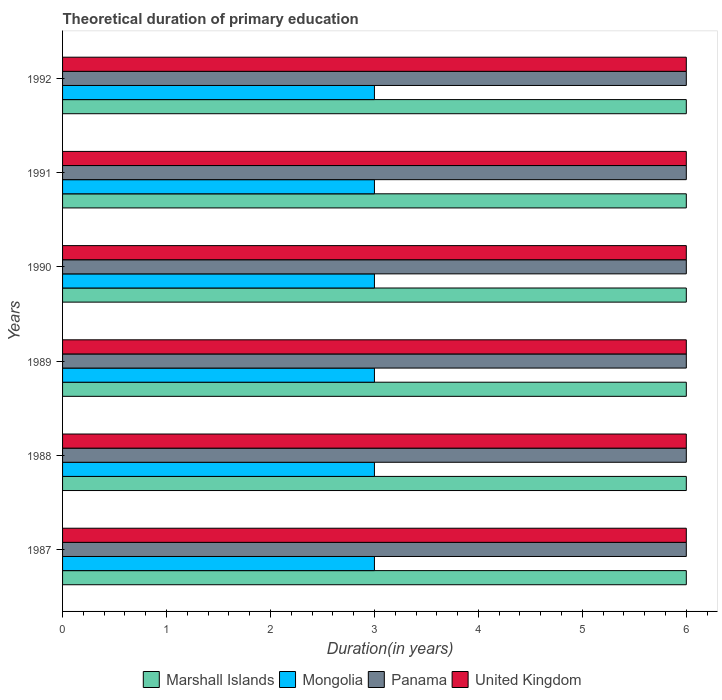Are the number of bars on each tick of the Y-axis equal?
Offer a terse response. Yes. How many bars are there on the 5th tick from the top?
Offer a very short reply. 4. Across all years, what is the maximum total theoretical duration of primary education in Mongolia?
Offer a very short reply. 3. In which year was the total theoretical duration of primary education in United Kingdom maximum?
Ensure brevity in your answer.  1987. What is the total total theoretical duration of primary education in Mongolia in the graph?
Make the answer very short. 18. What is the difference between the total theoretical duration of primary education in United Kingdom in 1987 and the total theoretical duration of primary education in Marshall Islands in 1988?
Give a very brief answer. 0. In the year 1991, what is the difference between the total theoretical duration of primary education in Marshall Islands and total theoretical duration of primary education in United Kingdom?
Keep it short and to the point. 0. In how many years, is the total theoretical duration of primary education in United Kingdom greater than 2.2 years?
Your answer should be compact. 6. What is the ratio of the total theoretical duration of primary education in Mongolia in 1988 to that in 1992?
Give a very brief answer. 1. Is the total theoretical duration of primary education in Mongolia in 1988 less than that in 1992?
Keep it short and to the point. No. Is the difference between the total theoretical duration of primary education in Marshall Islands in 1990 and 1992 greater than the difference between the total theoretical duration of primary education in United Kingdom in 1990 and 1992?
Make the answer very short. No. What is the difference between the highest and the lowest total theoretical duration of primary education in Panama?
Provide a succinct answer. 0. Is it the case that in every year, the sum of the total theoretical duration of primary education in Marshall Islands and total theoretical duration of primary education in Mongolia is greater than the sum of total theoretical duration of primary education in United Kingdom and total theoretical duration of primary education in Panama?
Ensure brevity in your answer.  No. What does the 3rd bar from the top in 1989 represents?
Provide a succinct answer. Mongolia. What does the 4th bar from the bottom in 1991 represents?
Offer a very short reply. United Kingdom. Is it the case that in every year, the sum of the total theoretical duration of primary education in Mongolia and total theoretical duration of primary education in Marshall Islands is greater than the total theoretical duration of primary education in Panama?
Ensure brevity in your answer.  Yes. Are all the bars in the graph horizontal?
Give a very brief answer. Yes. How many years are there in the graph?
Offer a very short reply. 6. Are the values on the major ticks of X-axis written in scientific E-notation?
Your answer should be compact. No. Where does the legend appear in the graph?
Offer a terse response. Bottom center. How many legend labels are there?
Your response must be concise. 4. What is the title of the graph?
Provide a succinct answer. Theoretical duration of primary education. What is the label or title of the X-axis?
Your answer should be compact. Duration(in years). What is the Duration(in years) in Marshall Islands in 1987?
Make the answer very short. 6. What is the Duration(in years) of Marshall Islands in 1988?
Provide a succinct answer. 6. What is the Duration(in years) in Panama in 1988?
Make the answer very short. 6. What is the Duration(in years) in Marshall Islands in 1989?
Keep it short and to the point. 6. What is the Duration(in years) in Marshall Islands in 1990?
Offer a very short reply. 6. What is the Duration(in years) in Panama in 1990?
Provide a short and direct response. 6. What is the Duration(in years) of Marshall Islands in 1991?
Offer a very short reply. 6. What is the Duration(in years) in Mongolia in 1991?
Your answer should be compact. 3. What is the Duration(in years) in Panama in 1991?
Ensure brevity in your answer.  6. What is the Duration(in years) in United Kingdom in 1991?
Make the answer very short. 6. What is the Duration(in years) in Marshall Islands in 1992?
Provide a succinct answer. 6. What is the Duration(in years) in Mongolia in 1992?
Your answer should be very brief. 3. What is the Duration(in years) in United Kingdom in 1992?
Give a very brief answer. 6. Across all years, what is the maximum Duration(in years) in Mongolia?
Your answer should be very brief. 3. Across all years, what is the maximum Duration(in years) of United Kingdom?
Your answer should be very brief. 6. Across all years, what is the minimum Duration(in years) of Marshall Islands?
Offer a terse response. 6. What is the total Duration(in years) of United Kingdom in the graph?
Your answer should be compact. 36. What is the difference between the Duration(in years) in Marshall Islands in 1987 and that in 1988?
Offer a terse response. 0. What is the difference between the Duration(in years) of Mongolia in 1987 and that in 1988?
Give a very brief answer. 0. What is the difference between the Duration(in years) of Mongolia in 1987 and that in 1990?
Make the answer very short. 0. What is the difference between the Duration(in years) of Marshall Islands in 1987 and that in 1991?
Your response must be concise. 0. What is the difference between the Duration(in years) in Panama in 1987 and that in 1991?
Your response must be concise. 0. What is the difference between the Duration(in years) of Panama in 1987 and that in 1992?
Give a very brief answer. 0. What is the difference between the Duration(in years) in Marshall Islands in 1988 and that in 1989?
Your answer should be compact. 0. What is the difference between the Duration(in years) in Panama in 1988 and that in 1989?
Make the answer very short. 0. What is the difference between the Duration(in years) in Mongolia in 1988 and that in 1990?
Make the answer very short. 0. What is the difference between the Duration(in years) in Panama in 1988 and that in 1991?
Your answer should be very brief. 0. What is the difference between the Duration(in years) in United Kingdom in 1988 and that in 1991?
Keep it short and to the point. 0. What is the difference between the Duration(in years) in Mongolia in 1988 and that in 1992?
Offer a terse response. 0. What is the difference between the Duration(in years) of Panama in 1988 and that in 1992?
Provide a short and direct response. 0. What is the difference between the Duration(in years) in Marshall Islands in 1989 and that in 1990?
Make the answer very short. 0. What is the difference between the Duration(in years) in United Kingdom in 1989 and that in 1990?
Offer a very short reply. 0. What is the difference between the Duration(in years) in Marshall Islands in 1989 and that in 1991?
Offer a very short reply. 0. What is the difference between the Duration(in years) of Panama in 1989 and that in 1991?
Give a very brief answer. 0. What is the difference between the Duration(in years) in United Kingdom in 1989 and that in 1991?
Offer a terse response. 0. What is the difference between the Duration(in years) of Marshall Islands in 1989 and that in 1992?
Offer a very short reply. 0. What is the difference between the Duration(in years) in Mongolia in 1989 and that in 1992?
Offer a terse response. 0. What is the difference between the Duration(in years) of United Kingdom in 1989 and that in 1992?
Provide a short and direct response. 0. What is the difference between the Duration(in years) in Mongolia in 1990 and that in 1991?
Offer a terse response. 0. What is the difference between the Duration(in years) of United Kingdom in 1990 and that in 1991?
Your answer should be compact. 0. What is the difference between the Duration(in years) in Marshall Islands in 1990 and that in 1992?
Your response must be concise. 0. What is the difference between the Duration(in years) of Mongolia in 1990 and that in 1992?
Offer a terse response. 0. What is the difference between the Duration(in years) in Marshall Islands in 1991 and that in 1992?
Your answer should be compact. 0. What is the difference between the Duration(in years) in Marshall Islands in 1987 and the Duration(in years) in Mongolia in 1988?
Provide a short and direct response. 3. What is the difference between the Duration(in years) in Marshall Islands in 1987 and the Duration(in years) in Panama in 1988?
Make the answer very short. 0. What is the difference between the Duration(in years) in Marshall Islands in 1987 and the Duration(in years) in United Kingdom in 1988?
Your response must be concise. 0. What is the difference between the Duration(in years) of Mongolia in 1987 and the Duration(in years) of Panama in 1988?
Provide a short and direct response. -3. What is the difference between the Duration(in years) in Marshall Islands in 1987 and the Duration(in years) in Mongolia in 1989?
Ensure brevity in your answer.  3. What is the difference between the Duration(in years) in Marshall Islands in 1987 and the Duration(in years) in United Kingdom in 1989?
Make the answer very short. 0. What is the difference between the Duration(in years) of Mongolia in 1987 and the Duration(in years) of Panama in 1989?
Your answer should be very brief. -3. What is the difference between the Duration(in years) in Mongolia in 1987 and the Duration(in years) in United Kingdom in 1989?
Keep it short and to the point. -3. What is the difference between the Duration(in years) in Marshall Islands in 1987 and the Duration(in years) in United Kingdom in 1990?
Offer a terse response. 0. What is the difference between the Duration(in years) in Mongolia in 1987 and the Duration(in years) in Panama in 1990?
Make the answer very short. -3. What is the difference between the Duration(in years) of Marshall Islands in 1987 and the Duration(in years) of Mongolia in 1991?
Offer a terse response. 3. What is the difference between the Duration(in years) in Mongolia in 1987 and the Duration(in years) in United Kingdom in 1991?
Your response must be concise. -3. What is the difference between the Duration(in years) in Mongolia in 1987 and the Duration(in years) in United Kingdom in 1992?
Your answer should be very brief. -3. What is the difference between the Duration(in years) of Marshall Islands in 1988 and the Duration(in years) of Mongolia in 1989?
Give a very brief answer. 3. What is the difference between the Duration(in years) in Marshall Islands in 1988 and the Duration(in years) in Panama in 1989?
Keep it short and to the point. 0. What is the difference between the Duration(in years) of Marshall Islands in 1988 and the Duration(in years) of United Kingdom in 1989?
Provide a short and direct response. 0. What is the difference between the Duration(in years) of Mongolia in 1988 and the Duration(in years) of United Kingdom in 1989?
Provide a succinct answer. -3. What is the difference between the Duration(in years) of Marshall Islands in 1988 and the Duration(in years) of Mongolia in 1990?
Keep it short and to the point. 3. What is the difference between the Duration(in years) of Marshall Islands in 1988 and the Duration(in years) of United Kingdom in 1990?
Keep it short and to the point. 0. What is the difference between the Duration(in years) of Mongolia in 1988 and the Duration(in years) of United Kingdom in 1990?
Offer a very short reply. -3. What is the difference between the Duration(in years) of Panama in 1988 and the Duration(in years) of United Kingdom in 1990?
Your answer should be very brief. 0. What is the difference between the Duration(in years) of Marshall Islands in 1988 and the Duration(in years) of United Kingdom in 1991?
Your answer should be compact. 0. What is the difference between the Duration(in years) of Mongolia in 1988 and the Duration(in years) of Panama in 1991?
Your response must be concise. -3. What is the difference between the Duration(in years) of Mongolia in 1988 and the Duration(in years) of United Kingdom in 1991?
Provide a succinct answer. -3. What is the difference between the Duration(in years) in Marshall Islands in 1988 and the Duration(in years) in Mongolia in 1992?
Your response must be concise. 3. What is the difference between the Duration(in years) of Mongolia in 1988 and the Duration(in years) of Panama in 1992?
Give a very brief answer. -3. What is the difference between the Duration(in years) in Mongolia in 1988 and the Duration(in years) in United Kingdom in 1992?
Give a very brief answer. -3. What is the difference between the Duration(in years) in Marshall Islands in 1989 and the Duration(in years) in United Kingdom in 1990?
Keep it short and to the point. 0. What is the difference between the Duration(in years) in Marshall Islands in 1989 and the Duration(in years) in United Kingdom in 1991?
Your response must be concise. 0. What is the difference between the Duration(in years) of Mongolia in 1989 and the Duration(in years) of Panama in 1991?
Make the answer very short. -3. What is the difference between the Duration(in years) of Mongolia in 1989 and the Duration(in years) of United Kingdom in 1991?
Keep it short and to the point. -3. What is the difference between the Duration(in years) of Marshall Islands in 1989 and the Duration(in years) of United Kingdom in 1992?
Keep it short and to the point. 0. What is the difference between the Duration(in years) in Mongolia in 1989 and the Duration(in years) in Panama in 1992?
Ensure brevity in your answer.  -3. What is the difference between the Duration(in years) of Mongolia in 1989 and the Duration(in years) of United Kingdom in 1992?
Provide a succinct answer. -3. What is the difference between the Duration(in years) of Panama in 1989 and the Duration(in years) of United Kingdom in 1992?
Your answer should be compact. 0. What is the difference between the Duration(in years) of Panama in 1990 and the Duration(in years) of United Kingdom in 1991?
Provide a succinct answer. 0. What is the difference between the Duration(in years) in Marshall Islands in 1990 and the Duration(in years) in Mongolia in 1992?
Your answer should be very brief. 3. What is the difference between the Duration(in years) of Marshall Islands in 1990 and the Duration(in years) of Panama in 1992?
Provide a succinct answer. 0. What is the difference between the Duration(in years) of Mongolia in 1991 and the Duration(in years) of Panama in 1992?
Offer a terse response. -3. What is the difference between the Duration(in years) of Mongolia in 1991 and the Duration(in years) of United Kingdom in 1992?
Your answer should be compact. -3. What is the difference between the Duration(in years) in Panama in 1991 and the Duration(in years) in United Kingdom in 1992?
Your answer should be very brief. 0. What is the average Duration(in years) in Marshall Islands per year?
Offer a very short reply. 6. What is the average Duration(in years) in United Kingdom per year?
Your answer should be compact. 6. In the year 1987, what is the difference between the Duration(in years) of Marshall Islands and Duration(in years) of Mongolia?
Offer a very short reply. 3. In the year 1987, what is the difference between the Duration(in years) of Marshall Islands and Duration(in years) of Panama?
Your answer should be very brief. 0. In the year 1987, what is the difference between the Duration(in years) of Panama and Duration(in years) of United Kingdom?
Keep it short and to the point. 0. In the year 1988, what is the difference between the Duration(in years) in Marshall Islands and Duration(in years) in Panama?
Keep it short and to the point. 0. In the year 1988, what is the difference between the Duration(in years) in Mongolia and Duration(in years) in United Kingdom?
Provide a short and direct response. -3. In the year 1989, what is the difference between the Duration(in years) of Marshall Islands and Duration(in years) of Mongolia?
Make the answer very short. 3. In the year 1989, what is the difference between the Duration(in years) in Mongolia and Duration(in years) in United Kingdom?
Keep it short and to the point. -3. In the year 1990, what is the difference between the Duration(in years) in Mongolia and Duration(in years) in Panama?
Keep it short and to the point. -3. In the year 1991, what is the difference between the Duration(in years) of Marshall Islands and Duration(in years) of Mongolia?
Offer a terse response. 3. In the year 1991, what is the difference between the Duration(in years) of Marshall Islands and Duration(in years) of United Kingdom?
Offer a very short reply. 0. In the year 1991, what is the difference between the Duration(in years) in Mongolia and Duration(in years) in Panama?
Your answer should be very brief. -3. In the year 1991, what is the difference between the Duration(in years) of Mongolia and Duration(in years) of United Kingdom?
Give a very brief answer. -3. In the year 1992, what is the difference between the Duration(in years) of Marshall Islands and Duration(in years) of United Kingdom?
Provide a succinct answer. 0. What is the ratio of the Duration(in years) of Marshall Islands in 1987 to that in 1988?
Your answer should be very brief. 1. What is the ratio of the Duration(in years) in Mongolia in 1987 to that in 1988?
Make the answer very short. 1. What is the ratio of the Duration(in years) of Marshall Islands in 1987 to that in 1989?
Offer a very short reply. 1. What is the ratio of the Duration(in years) of United Kingdom in 1987 to that in 1989?
Offer a very short reply. 1. What is the ratio of the Duration(in years) in Mongolia in 1987 to that in 1990?
Provide a succinct answer. 1. What is the ratio of the Duration(in years) in Marshall Islands in 1987 to that in 1991?
Your response must be concise. 1. What is the ratio of the Duration(in years) in Mongolia in 1987 to that in 1991?
Offer a terse response. 1. What is the ratio of the Duration(in years) of Panama in 1987 to that in 1992?
Provide a short and direct response. 1. What is the ratio of the Duration(in years) in United Kingdom in 1987 to that in 1992?
Provide a succinct answer. 1. What is the ratio of the Duration(in years) in Mongolia in 1988 to that in 1989?
Offer a very short reply. 1. What is the ratio of the Duration(in years) of Panama in 1988 to that in 1989?
Your answer should be compact. 1. What is the ratio of the Duration(in years) in United Kingdom in 1988 to that in 1989?
Offer a very short reply. 1. What is the ratio of the Duration(in years) of Mongolia in 1988 to that in 1990?
Your answer should be very brief. 1. What is the ratio of the Duration(in years) of Panama in 1988 to that in 1990?
Your answer should be compact. 1. What is the ratio of the Duration(in years) of United Kingdom in 1988 to that in 1990?
Offer a very short reply. 1. What is the ratio of the Duration(in years) of Panama in 1988 to that in 1992?
Your answer should be compact. 1. What is the ratio of the Duration(in years) in Mongolia in 1989 to that in 1990?
Ensure brevity in your answer.  1. What is the ratio of the Duration(in years) in Marshall Islands in 1989 to that in 1991?
Offer a terse response. 1. What is the ratio of the Duration(in years) of Panama in 1989 to that in 1991?
Keep it short and to the point. 1. What is the ratio of the Duration(in years) in United Kingdom in 1989 to that in 1991?
Keep it short and to the point. 1. What is the ratio of the Duration(in years) of Marshall Islands in 1989 to that in 1992?
Give a very brief answer. 1. What is the ratio of the Duration(in years) of Marshall Islands in 1990 to that in 1991?
Make the answer very short. 1. What is the ratio of the Duration(in years) of Mongolia in 1990 to that in 1991?
Provide a succinct answer. 1. What is the ratio of the Duration(in years) of United Kingdom in 1990 to that in 1991?
Give a very brief answer. 1. What is the ratio of the Duration(in years) of Panama in 1990 to that in 1992?
Provide a short and direct response. 1. What is the ratio of the Duration(in years) of United Kingdom in 1990 to that in 1992?
Give a very brief answer. 1. What is the ratio of the Duration(in years) of United Kingdom in 1991 to that in 1992?
Ensure brevity in your answer.  1. What is the difference between the highest and the second highest Duration(in years) of Panama?
Provide a short and direct response. 0. What is the difference between the highest and the second highest Duration(in years) of United Kingdom?
Your answer should be compact. 0. What is the difference between the highest and the lowest Duration(in years) of Marshall Islands?
Offer a terse response. 0. What is the difference between the highest and the lowest Duration(in years) of Mongolia?
Your response must be concise. 0. What is the difference between the highest and the lowest Duration(in years) in Panama?
Your answer should be compact. 0. 